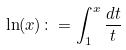<formula> <loc_0><loc_0><loc_500><loc_500>\ln ( x ) \colon = \int _ { 1 } ^ { x } \frac { d t } { t }</formula> 